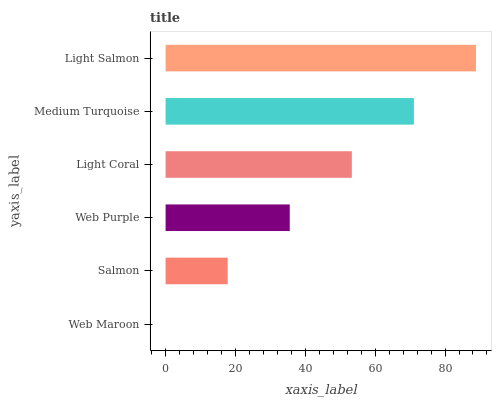Is Web Maroon the minimum?
Answer yes or no. Yes. Is Light Salmon the maximum?
Answer yes or no. Yes. Is Salmon the minimum?
Answer yes or no. No. Is Salmon the maximum?
Answer yes or no. No. Is Salmon greater than Web Maroon?
Answer yes or no. Yes. Is Web Maroon less than Salmon?
Answer yes or no. Yes. Is Web Maroon greater than Salmon?
Answer yes or no. No. Is Salmon less than Web Maroon?
Answer yes or no. No. Is Light Coral the high median?
Answer yes or no. Yes. Is Web Purple the low median?
Answer yes or no. Yes. Is Web Maroon the high median?
Answer yes or no. No. Is Light Salmon the low median?
Answer yes or no. No. 